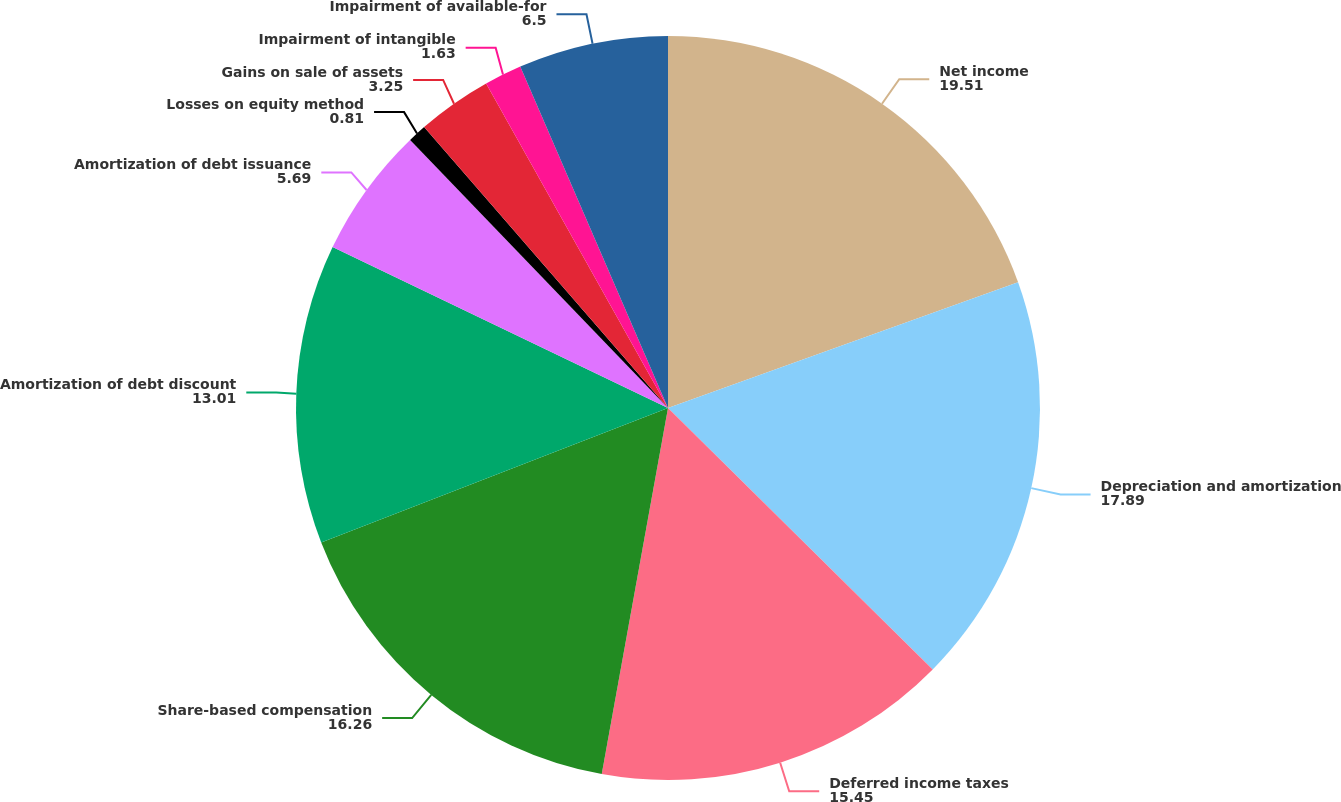Convert chart. <chart><loc_0><loc_0><loc_500><loc_500><pie_chart><fcel>Net income<fcel>Depreciation and amortization<fcel>Deferred income taxes<fcel>Share-based compensation<fcel>Amortization of debt discount<fcel>Amortization of debt issuance<fcel>Losses on equity method<fcel>Gains on sale of assets<fcel>Impairment of intangible<fcel>Impairment of available-for<nl><fcel>19.51%<fcel>17.89%<fcel>15.45%<fcel>16.26%<fcel>13.01%<fcel>5.69%<fcel>0.81%<fcel>3.25%<fcel>1.63%<fcel>6.5%<nl></chart> 